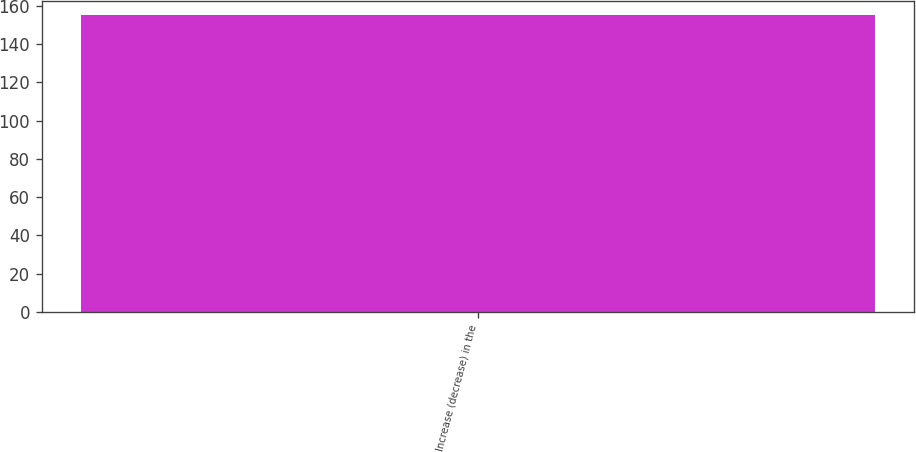Convert chart to OTSL. <chart><loc_0><loc_0><loc_500><loc_500><bar_chart><fcel>Increase (decrease) in the<nl><fcel>155<nl></chart> 